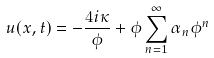<formula> <loc_0><loc_0><loc_500><loc_500>u ( x , t ) = - \frac { 4 i \kappa } { \phi } + \phi \sum _ { n = 1 } ^ { \infty } \alpha _ { n } \phi ^ { n }</formula> 